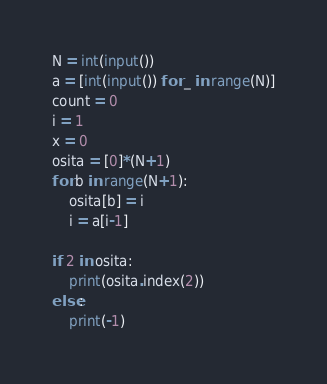<code> <loc_0><loc_0><loc_500><loc_500><_Python_>N = int(input())
a = [int(input()) for _ in range(N)]
count = 0
i = 1
x = 0
osita = [0]*(N+1)
for b in range(N+1):
    osita[b] = i
    i = a[i-1]
    
if 2 in osita:
    print(osita.index(2))
else:
    print(-1)</code> 